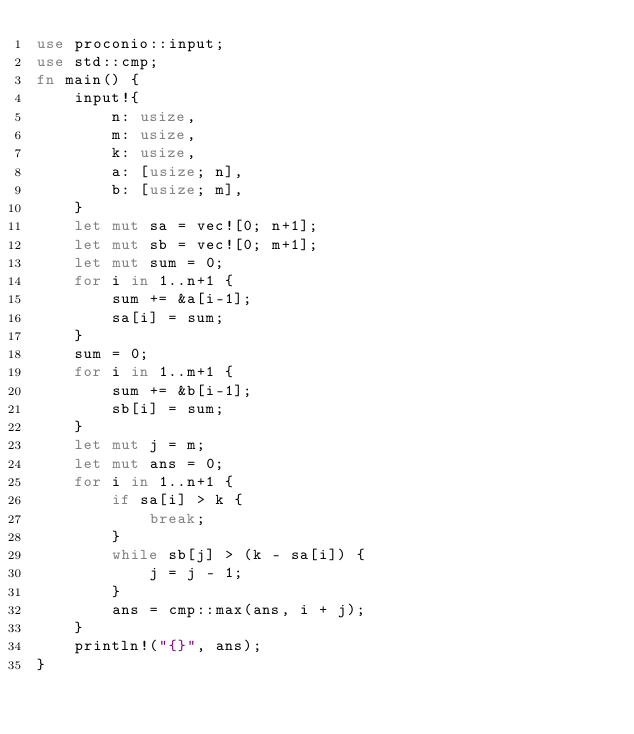<code> <loc_0><loc_0><loc_500><loc_500><_Rust_>use proconio::input;
use std::cmp;
fn main() {
    input!{
        n: usize,
        m: usize,
        k: usize,
        a: [usize; n],
        b: [usize; m],
    }
    let mut sa = vec![0; n+1];
    let mut sb = vec![0; m+1];
    let mut sum = 0;
    for i in 1..n+1 {
        sum += &a[i-1];
        sa[i] = sum;
    }
    sum = 0;
    for i in 1..m+1 {
        sum += &b[i-1];
        sb[i] = sum;
    }
    let mut j = m;
    let mut ans = 0;
    for i in 1..n+1 {
        if sa[i] > k {
            break;
        }
        while sb[j] > (k - sa[i]) {
            j = j - 1;
        }
        ans = cmp::max(ans, i + j);
    }
    println!("{}", ans);
}</code> 